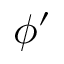Convert formula to latex. <formula><loc_0><loc_0><loc_500><loc_500>\phi ^ { \prime }</formula> 